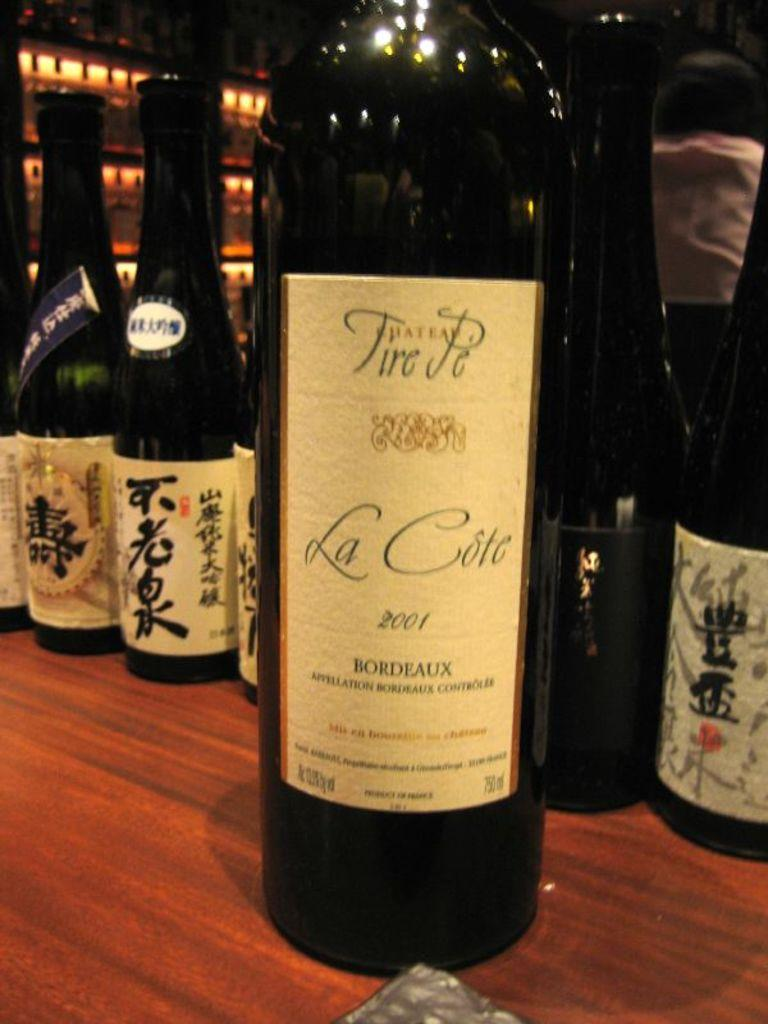<image>
Provide a brief description of the given image. Fire Je La Cote bottle of wine from the year 2001. 